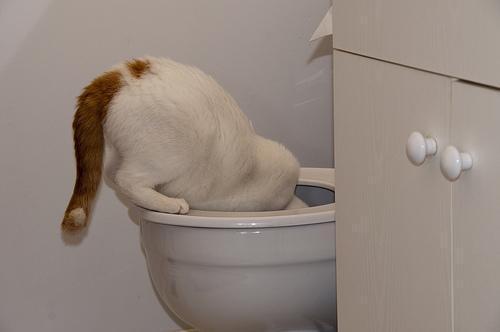How many cats are there?
Give a very brief answer. 1. 